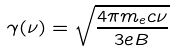Convert formula to latex. <formula><loc_0><loc_0><loc_500><loc_500>\gamma ( \nu ) = \sqrt { \frac { 4 \pi m _ { e } c \nu } { 3 e B } }</formula> 